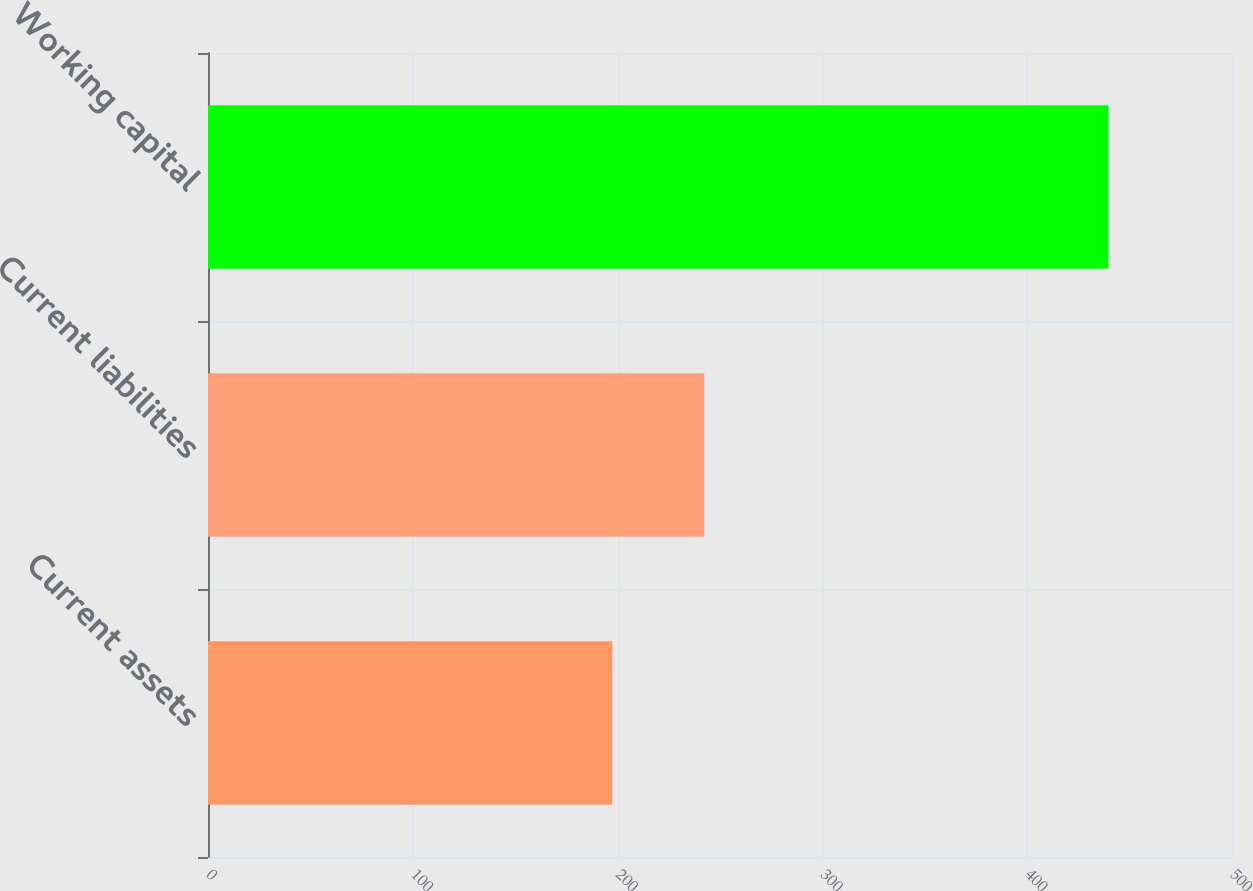<chart> <loc_0><loc_0><loc_500><loc_500><bar_chart><fcel>Current assets<fcel>Current liabilities<fcel>Working capital<nl><fcel>197.4<fcel>242.3<fcel>439.7<nl></chart> 